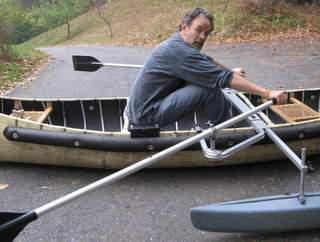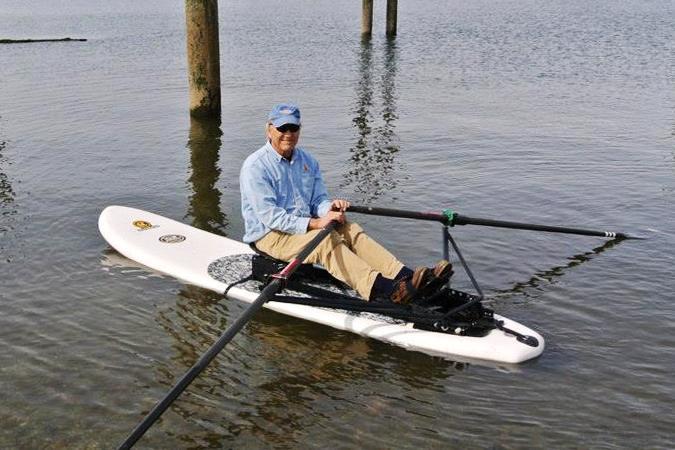The first image is the image on the left, the second image is the image on the right. Evaluate the accuracy of this statement regarding the images: "The left and right image contains the same number of small crafts in the water.". Is it true? Answer yes or no. No. The first image is the image on the left, the second image is the image on the right. For the images displayed, is the sentence "An image shows a man without a cap sitting in a traditional canoe gripping an oar in each hand, with his arms and body in position to pull the oars back." factually correct? Answer yes or no. Yes. 